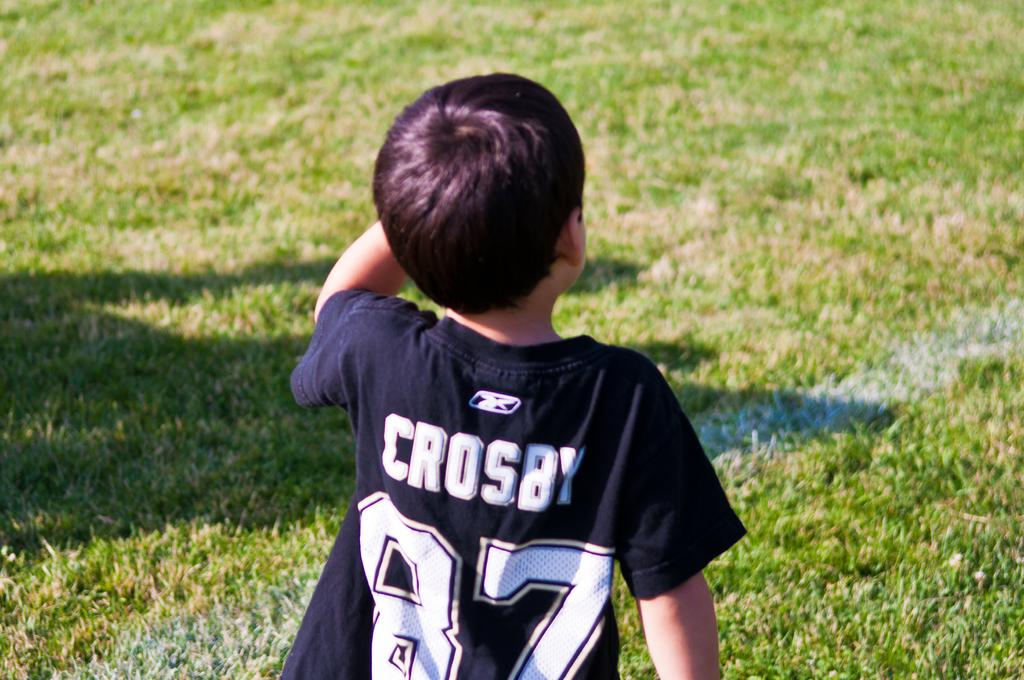<image>
Describe the image concisely. Little boy looking onward the field wearing a Crosby 87 shirt. 